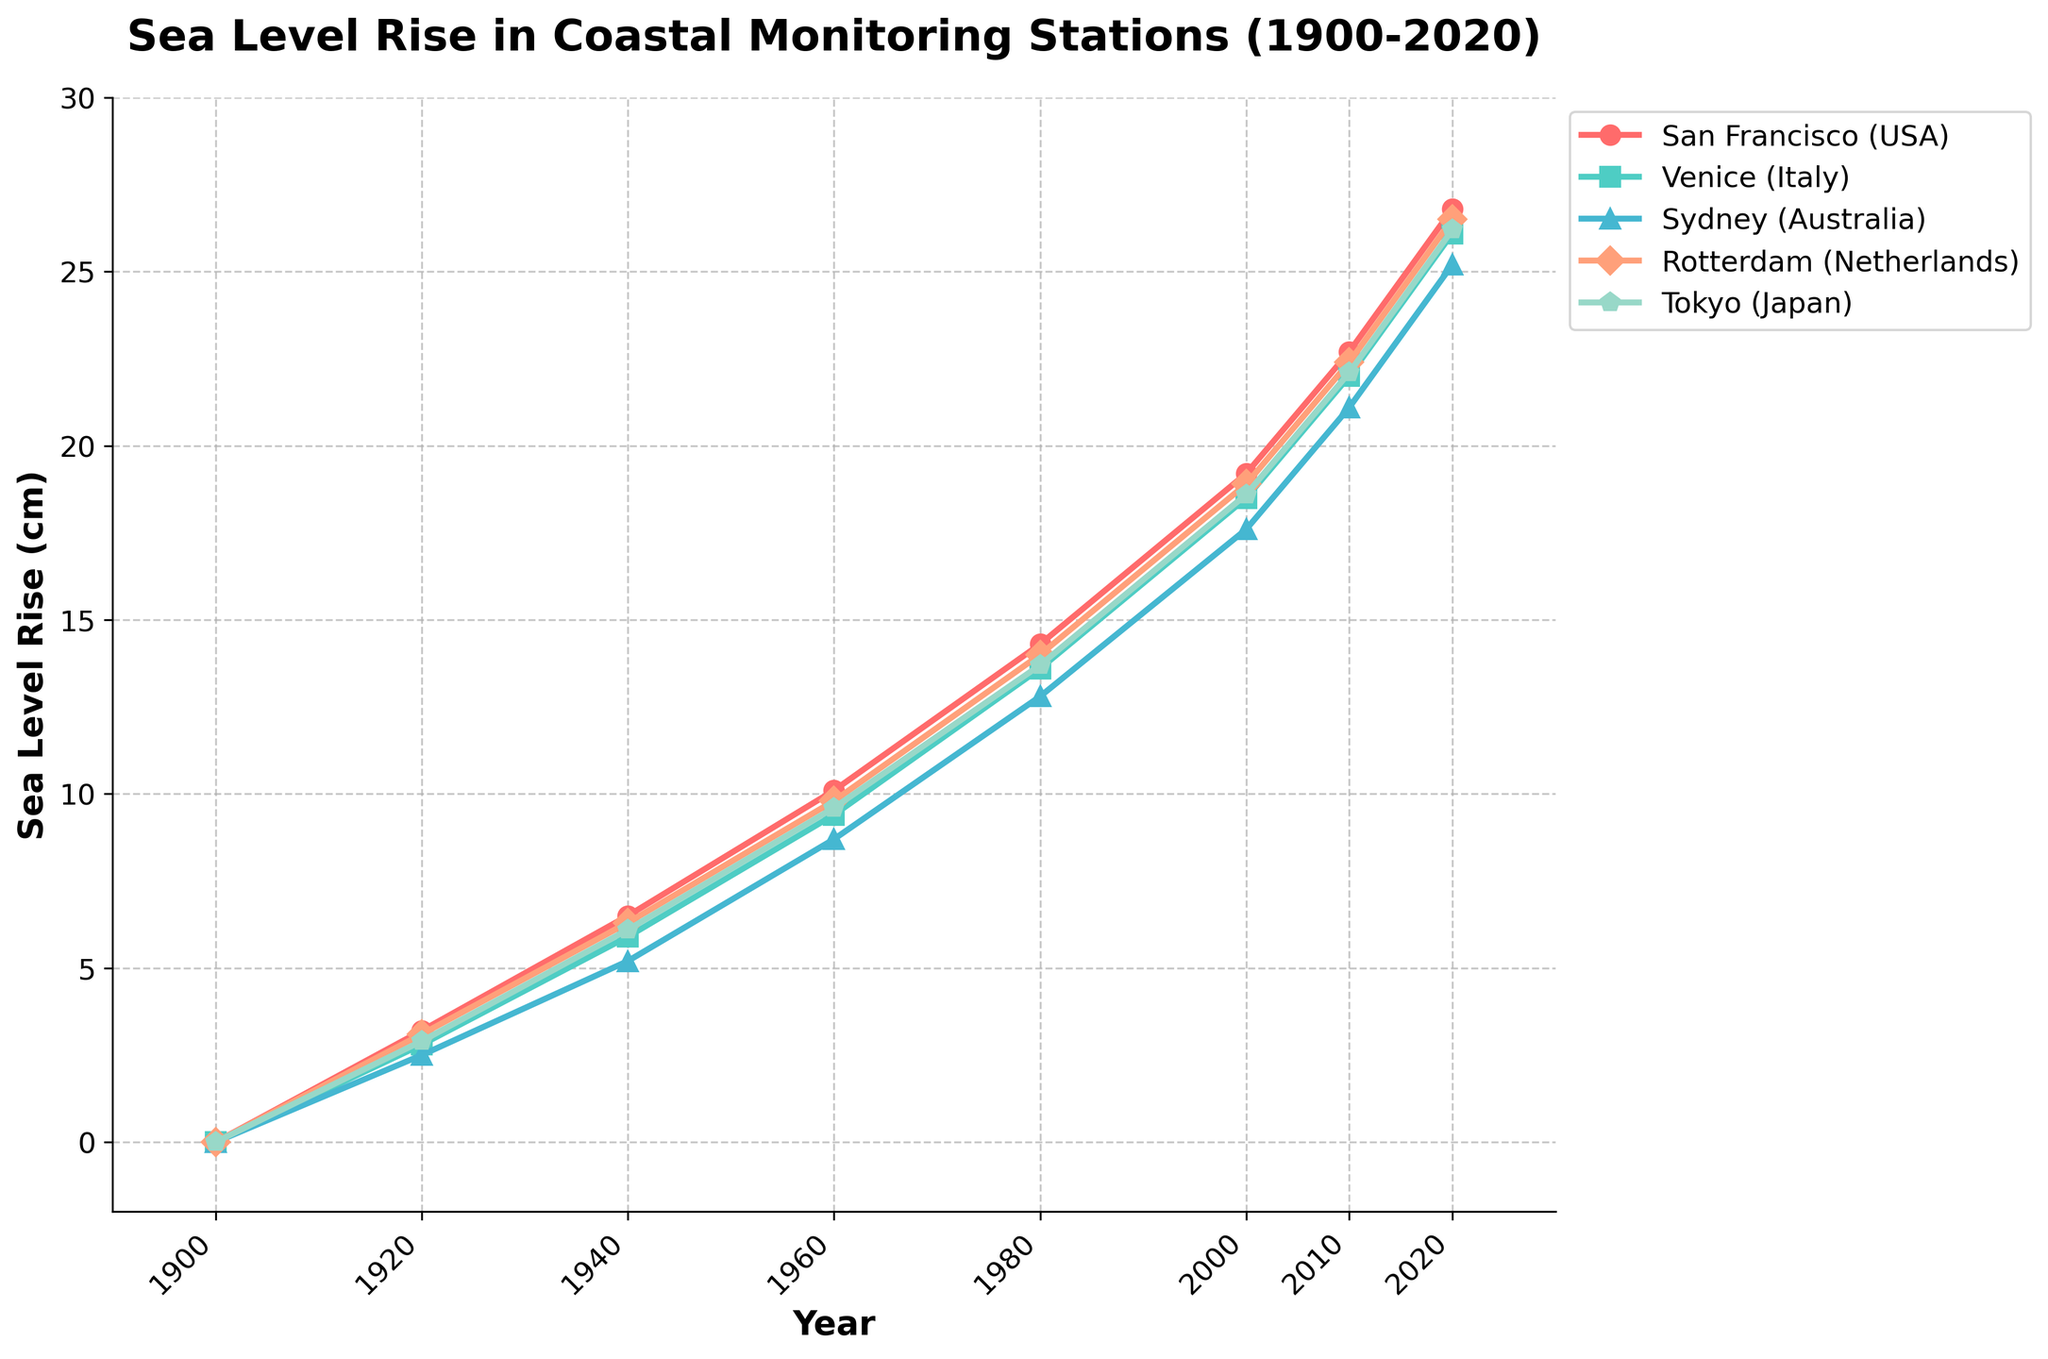Which coastal monitoring station had the highest sea level rise in 1960? Look at the figure data for the year 1960, then identify the station with the highest measurement. The station with the highest sea level rise is Tokyo (Japan) with 9.6 cm.
Answer: Tokyo (Japan) By how many centimeters did the sea level in San Francisco increase from 2000 to 2010? Find the values for San Francisco in 2000 and 2010, then subtract the 2000 value from the 2010 value. That's 22.7 cm - 19.2 cm = 3.5 cm.
Answer: 3.5 cm Out of the five cities, which one had the second-highest sea level rise in 2020? Look at the figure for the year 2020 and rank the cities by their sea level rise. The station with the second-highest sea level rise is Venice (Italy) with 26.1 cm, following San Francisco (USA) at 26.8 cm.
Answer: Venice (Italy) What is the average sea level rise for Venice in 1920, 1960, and 2020 combined? Add the values for Venice (2.8 cm, 9.4 cm, and 26.1 cm) and then divide by 3. The calculation is (2.8 + 9.4 + 26.1)/3 = 38.3/3 ≈ 12.8 cm.
Answer: 12.8 cm Which two cities had the same sea level rise in any given year, and what was that measurement? Compare the values of different cities to identify matching sea levels. In 1920, Rotterdam (Netherlands) and Tokyo (Japan) both had a sea level rise of 3.1 cm.
Answer: Rotterdam (Netherlands) and Tokyo (Japan), 3.1 cm How much more has the sea risen in Rotterdam compared to Sydney by 2020? Find the difference between the sea level rise in Rotterdam (26.5 cm) and Sydney (25.2 cm) by 2020. The difference is 26.5 cm - 25.2 cm = 1.3 cm.
Answer: 1.3 cm What is the trend of sea level rise in Venice from 1900 to 2020? Observe the pattern of increasing values for Venice across the years. The trend indicates a consistent increase in sea level rise from 0 cm in 1900 to 26.1 cm in 2020.
Answer: Consistent increase Compare the sea level rise in Tokyo and Sydney in 1980. Which city had a greater increase and by how much? Look at Tokyo and Sydney in 1980; Tokyo had 13.7 cm, and Sydney had 12.8 cm. The difference is 13.7 cm - 12.8 cm = 0.9 cm.
Answer: Tokyo, 0.9 cm 